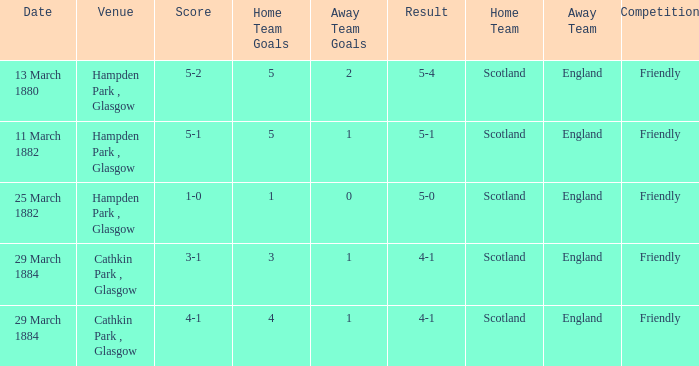Which competition had a 4-1 result, and a score of 4-1? Friendly. 